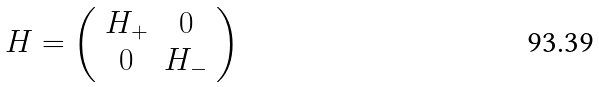<formula> <loc_0><loc_0><loc_500><loc_500>H = \left ( \begin{array} { c c } H _ { + } & 0 \\ 0 & H _ { - } \end{array} \right )</formula> 